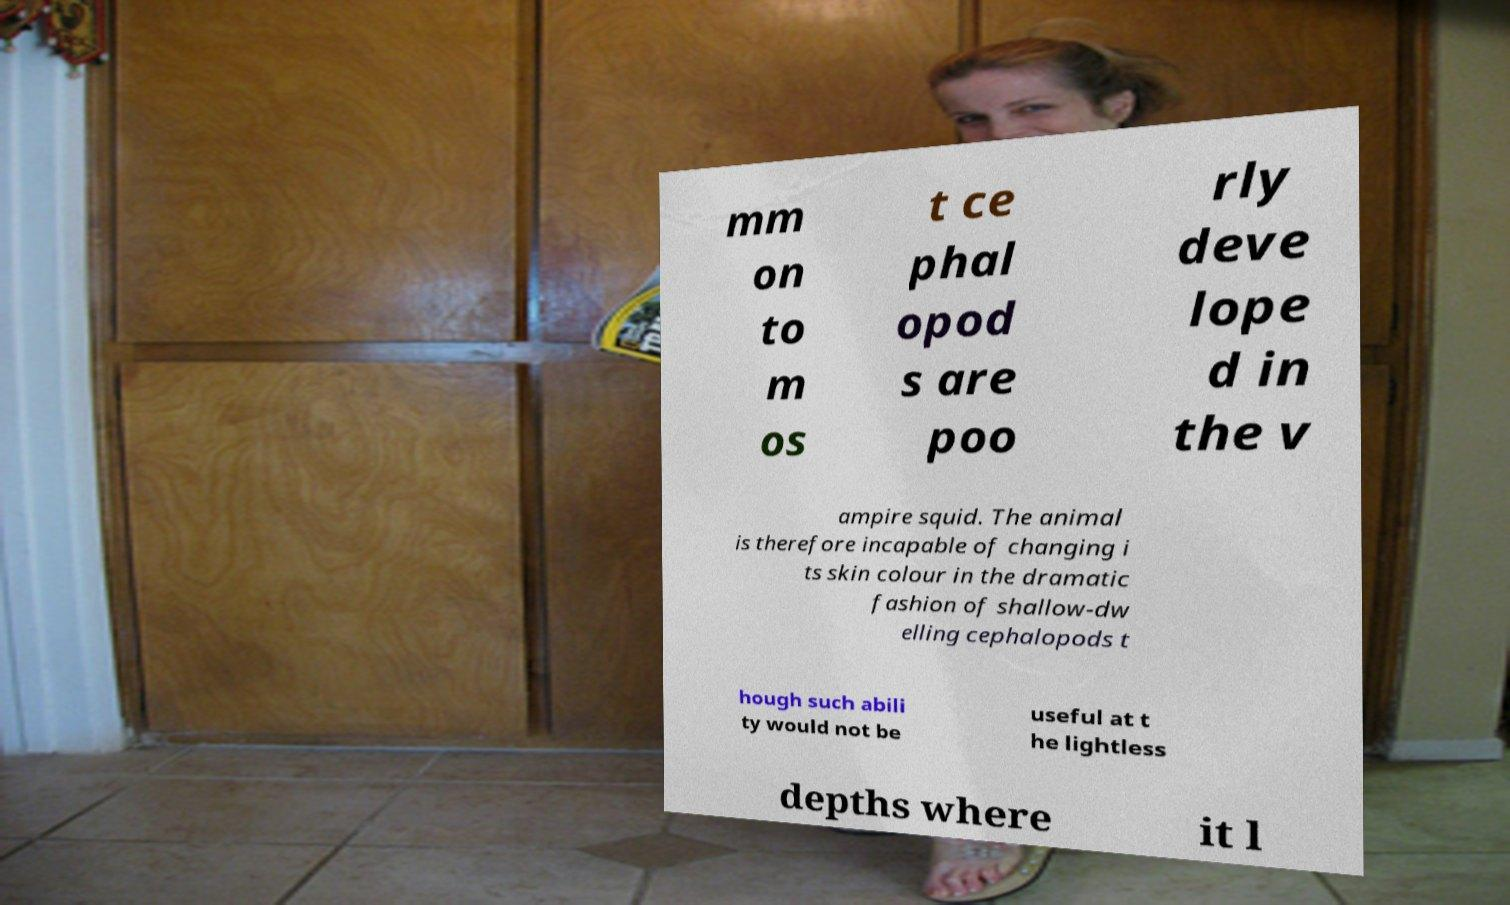Could you assist in decoding the text presented in this image and type it out clearly? mm on to m os t ce phal opod s are poo rly deve lope d in the v ampire squid. The animal is therefore incapable of changing i ts skin colour in the dramatic fashion of shallow-dw elling cephalopods t hough such abili ty would not be useful at t he lightless depths where it l 